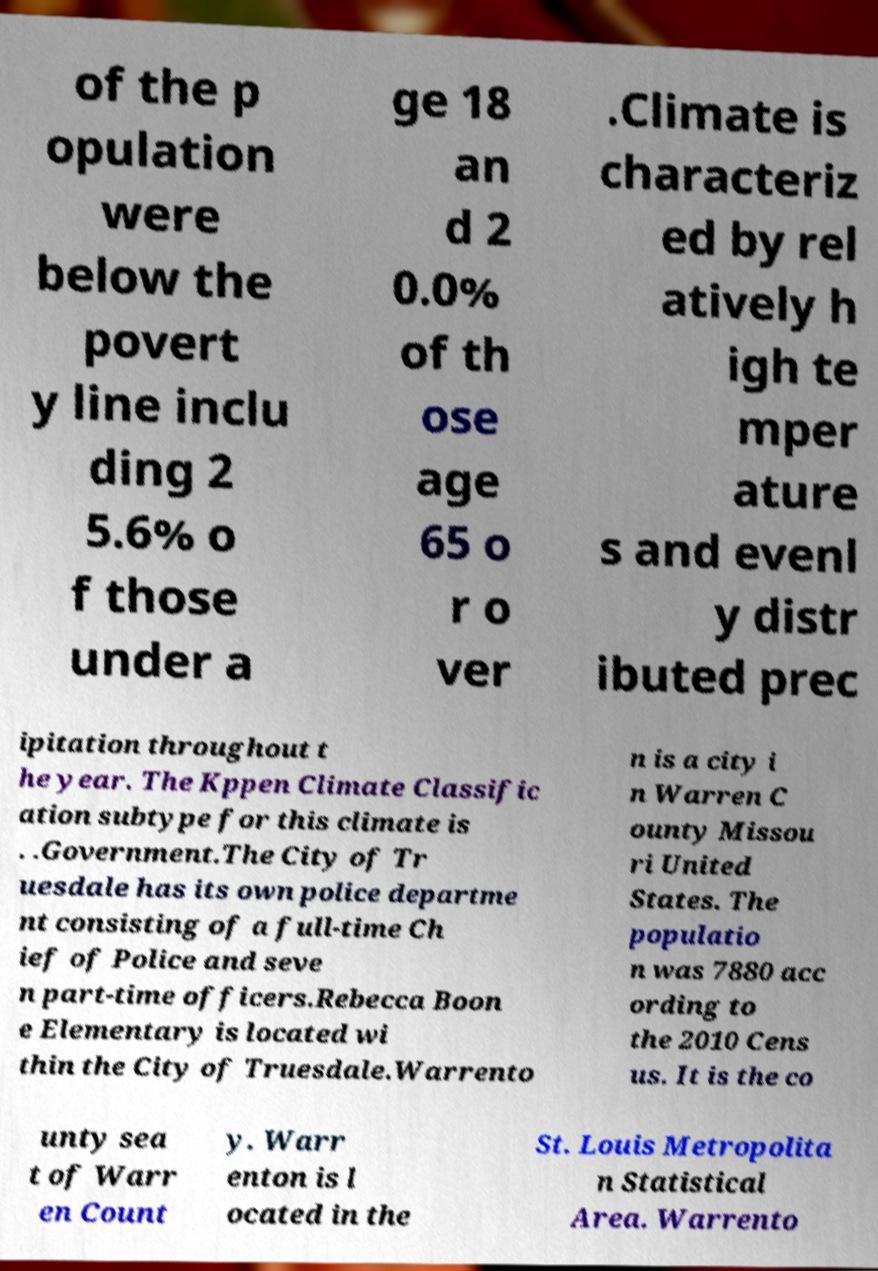Can you accurately transcribe the text from the provided image for me? of the p opulation were below the povert y line inclu ding 2 5.6% o f those under a ge 18 an d 2 0.0% of th ose age 65 o r o ver .Climate is characteriz ed by rel atively h igh te mper ature s and evenl y distr ibuted prec ipitation throughout t he year. The Kppen Climate Classific ation subtype for this climate is . .Government.The City of Tr uesdale has its own police departme nt consisting of a full-time Ch ief of Police and seve n part-time officers.Rebecca Boon e Elementary is located wi thin the City of Truesdale.Warrento n is a city i n Warren C ounty Missou ri United States. The populatio n was 7880 acc ording to the 2010 Cens us. It is the co unty sea t of Warr en Count y. Warr enton is l ocated in the St. Louis Metropolita n Statistical Area. Warrento 